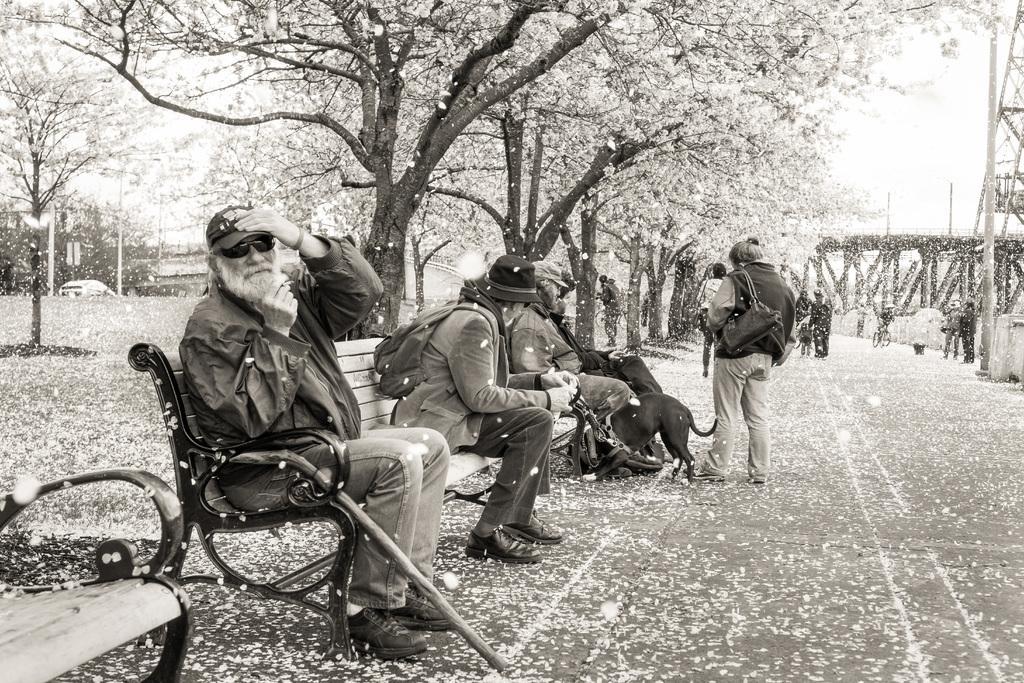How would you summarize this image in a sentence or two? Here is an old man carrying stick sat on the bench, he is wearing spectacles and cap. He is watching someone. Next to him, left to him, we see a person wearing hat black hat and wearing bag. He is holding dog with a leach. Next to that person, we see a man wearing cap is sitting on the same bench and also the other man is also sitting on the same bench. To the right, we find the woman wearing handbag and standing on the road. Back of her, we see many people standing on the road. To the left of her, we see trees and also the sky. We see snow falling down in this case. 